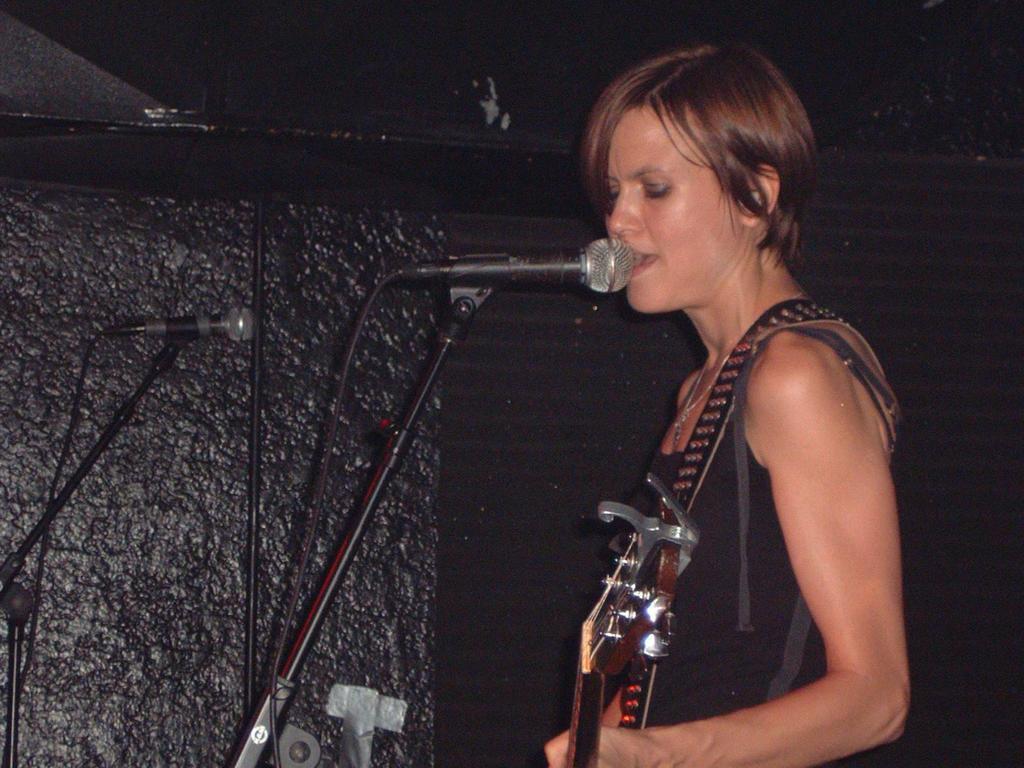In one or two sentences, can you explain what this image depicts? In the picture a woman is standing she is singing a song, she is wearing a guitar around her shoulder, in the background there is a black color wall. 